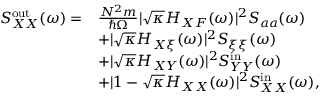<formula> <loc_0><loc_0><loc_500><loc_500>\begin{array} { r l } { S _ { X X } ^ { o u t } ( \omega ) = } & { \frac { N ^ { 2 } m } { \hbar { \Omega } } | \sqrt { \kappa } H _ { X F } ( \omega ) | ^ { 2 } S _ { a a } ( \omega ) } \\ & { + | \sqrt { \kappa } H _ { X \xi } ( \omega ) | ^ { 2 } S _ { \xi \xi } ( \omega ) } \\ & { + | \sqrt { \kappa } H _ { X Y } ( \omega ) | ^ { 2 } S _ { Y Y } ^ { i n } ( \omega ) } \\ & { + | 1 - \sqrt { \kappa } H _ { X X } ( \omega ) | ^ { 2 } S _ { X X } ^ { i n } ( \omega ) , } \end{array}</formula> 